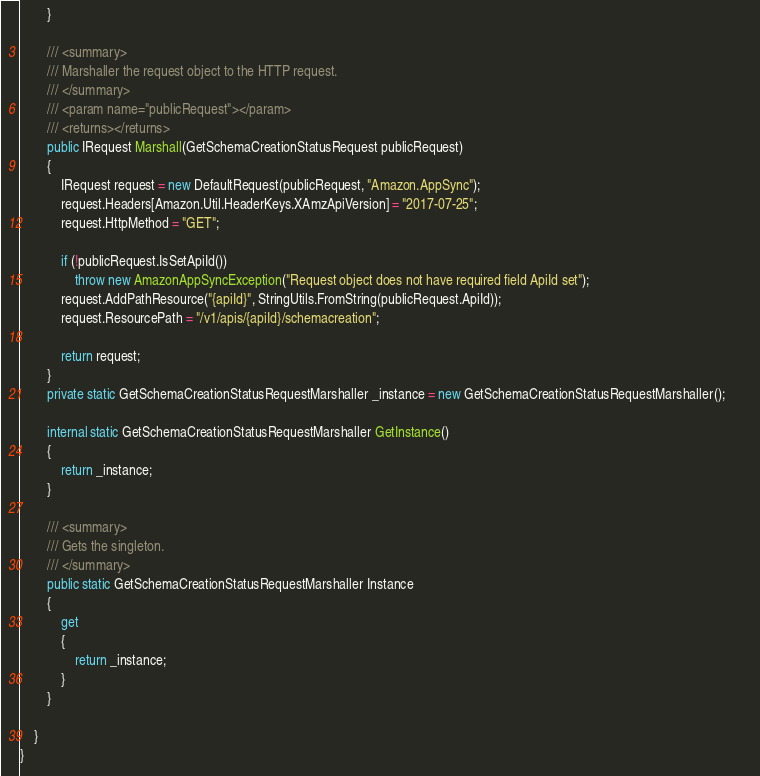<code> <loc_0><loc_0><loc_500><loc_500><_C#_>        }

        /// <summary>
        /// Marshaller the request object to the HTTP request.
        /// </summary>  
        /// <param name="publicRequest"></param>
        /// <returns></returns>
        public IRequest Marshall(GetSchemaCreationStatusRequest publicRequest)
        {
            IRequest request = new DefaultRequest(publicRequest, "Amazon.AppSync");
            request.Headers[Amazon.Util.HeaderKeys.XAmzApiVersion] = "2017-07-25";            
            request.HttpMethod = "GET";

            if (!publicRequest.IsSetApiId())
                throw new AmazonAppSyncException("Request object does not have required field ApiId set");
            request.AddPathResource("{apiId}", StringUtils.FromString(publicRequest.ApiId));
            request.ResourcePath = "/v1/apis/{apiId}/schemacreation";

            return request;
        }
        private static GetSchemaCreationStatusRequestMarshaller _instance = new GetSchemaCreationStatusRequestMarshaller();        

        internal static GetSchemaCreationStatusRequestMarshaller GetInstance()
        {
            return _instance;
        }

        /// <summary>
        /// Gets the singleton.
        /// </summary>  
        public static GetSchemaCreationStatusRequestMarshaller Instance
        {
            get
            {
                return _instance;
            }
        }

    }
}</code> 